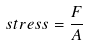Convert formula to latex. <formula><loc_0><loc_0><loc_500><loc_500>s t r e s s = \frac { F } { A }</formula> 